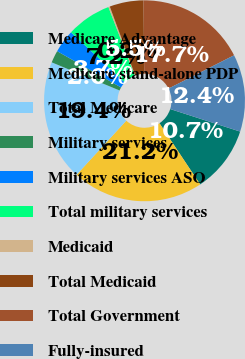Convert chart. <chart><loc_0><loc_0><loc_500><loc_500><pie_chart><fcel>Medicare Advantage<fcel>Medicare stand-alone PDP<fcel>Total Medicare<fcel>Military services<fcel>Military services ASO<fcel>Total military services<fcel>Medicaid<fcel>Total Medicaid<fcel>Total Government<fcel>Fully-insured<nl><fcel>10.7%<fcel>21.17%<fcel>19.43%<fcel>1.97%<fcel>3.72%<fcel>7.21%<fcel>0.23%<fcel>5.46%<fcel>17.68%<fcel>12.44%<nl></chart> 